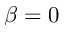Convert formula to latex. <formula><loc_0><loc_0><loc_500><loc_500>\beta = 0</formula> 